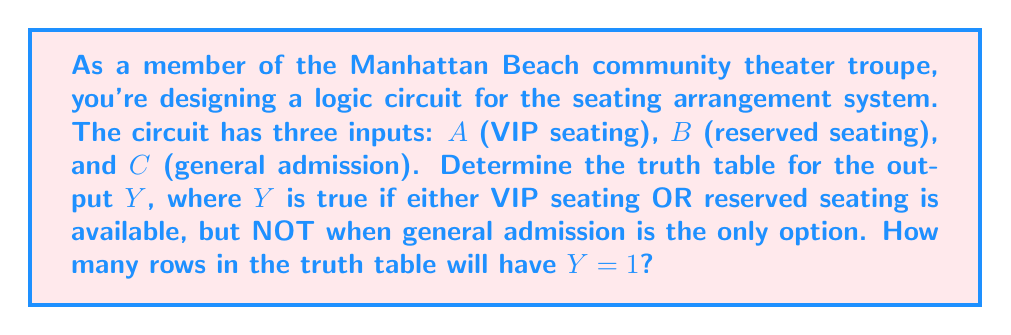Give your solution to this math problem. Let's approach this step-by-step:

1) First, we need to understand the logic: 
   Y = (A OR B) AND (NOT C ALONE)

2) We can represent this in Boolean algebra as:
   $$Y = (A + B) \cdot \overline{(¬A \cdot ¬B \cdot C)}$$

3) Now, let's create the truth table:

   | A | B | C | A + B | ¬A · ¬B · C | ¬(¬A · ¬B · C) | Y |
   |---|---|---|-------|-------------|-----------------|---|
   | 0 | 0 | 0 |   0   |      0      |        1        | 0 |
   | 0 | 0 | 1 |   0   |      1      |        0        | 0 |
   | 0 | 1 | 0 |   1   |      0      |        1        | 1 |
   | 0 | 1 | 1 |   1   |      0      |        1        | 1 |
   | 1 | 0 | 0 |   1   |      0      |        1        | 1 |
   | 1 | 0 | 1 |   1   |      0      |        1        | 1 |
   | 1 | 1 | 0 |   1   |      0      |        1        | 1 |
   | 1 | 1 | 1 |   1   |      0      |        1        | 1 |

4) Count the number of rows where Y = 1. There are 6 such rows.
Answer: 6 